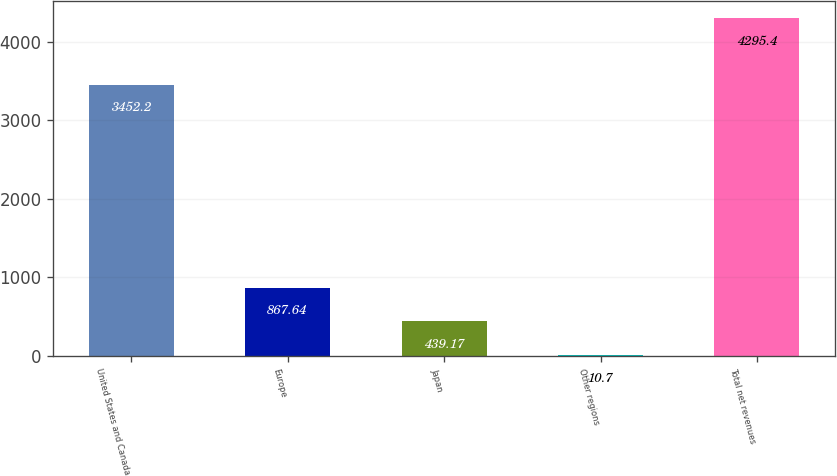Convert chart. <chart><loc_0><loc_0><loc_500><loc_500><bar_chart><fcel>United States and Canada<fcel>Europe<fcel>Japan<fcel>Other regions<fcel>Total net revenues<nl><fcel>3452.2<fcel>867.64<fcel>439.17<fcel>10.7<fcel>4295.4<nl></chart> 